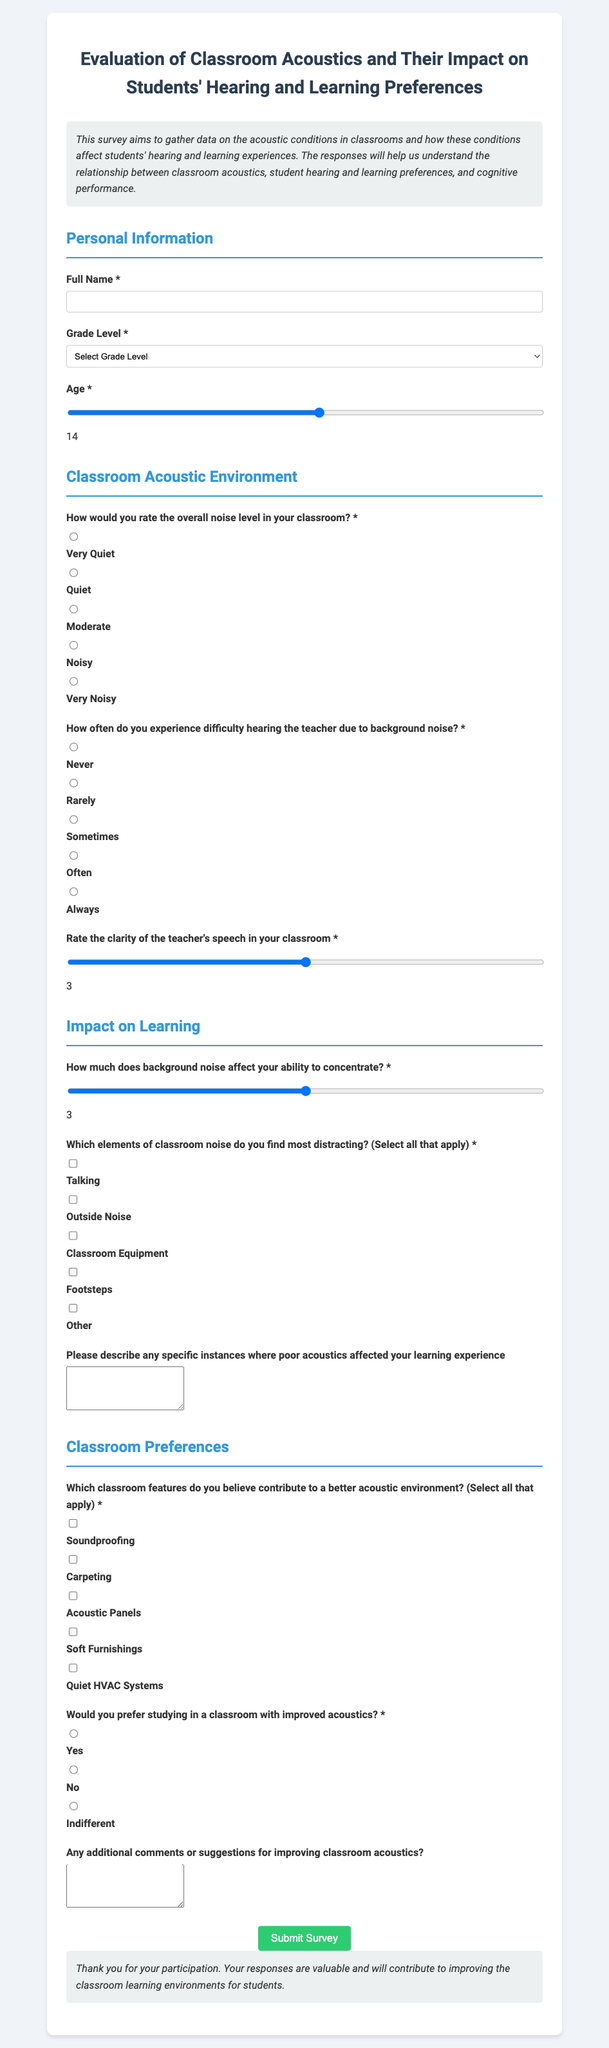What is the title of the survey? The title of the survey is displayed prominently at the top of the document.
Answer: Evaluation of Classroom Acoustics and Their Impact on Students' Hearing and Learning Preferences How many grade levels are listed in the survey? The survey presents a selection of grade levels for respondents to choose from.
Answer: Five What is the minimum age option provided in the age range? The age range input specifies the minimum age allowed for responses in the survey.
Answer: Five How often do you experience difficulty hearing the teacher due to background noise? This question asks respondents to select a frequency regarding their hearing difficulty encountered in the classroom.
Answer: Radio button selection What is one acoustic feature that respondents can select as contributing to a better learning environment? Respondents can choose multiple features related to acoustics in the classroom.
Answer: Soundproofing What is the purpose of this survey? The introduction section describes the main goal behind conducting the survey.
Answer: To gather data on the acoustic conditions in classrooms and their impact on students' experiences What is the highest rating on the speech clarity scale? The speech clarity input uses a range scale that includes maximum and minimum values.
Answer: Five Which type of feedback is requested regarding classroom acoustics? A specific open-ended question is included in the survey for detailed feedback on acoustics.
Answer: Describe instances of poor acoustics affecting learning Would you prefer studying in a classroom with improved acoustics? This question gauges students' preferences regarding their learning environment and acoustics.
Answer: Radio button selection 